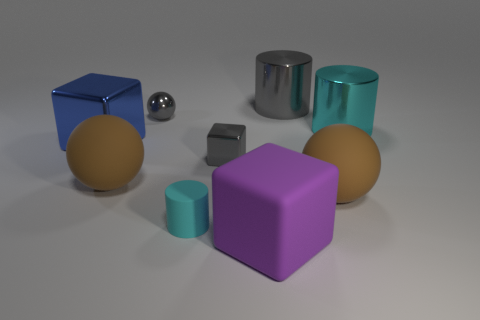Add 1 large cyan matte things. How many objects exist? 10 Subtract all blocks. How many objects are left? 6 Subtract 2 brown balls. How many objects are left? 7 Subtract all small cylinders. Subtract all brown things. How many objects are left? 6 Add 7 blue metal cubes. How many blue metal cubes are left? 8 Add 7 brown shiny cylinders. How many brown shiny cylinders exist? 7 